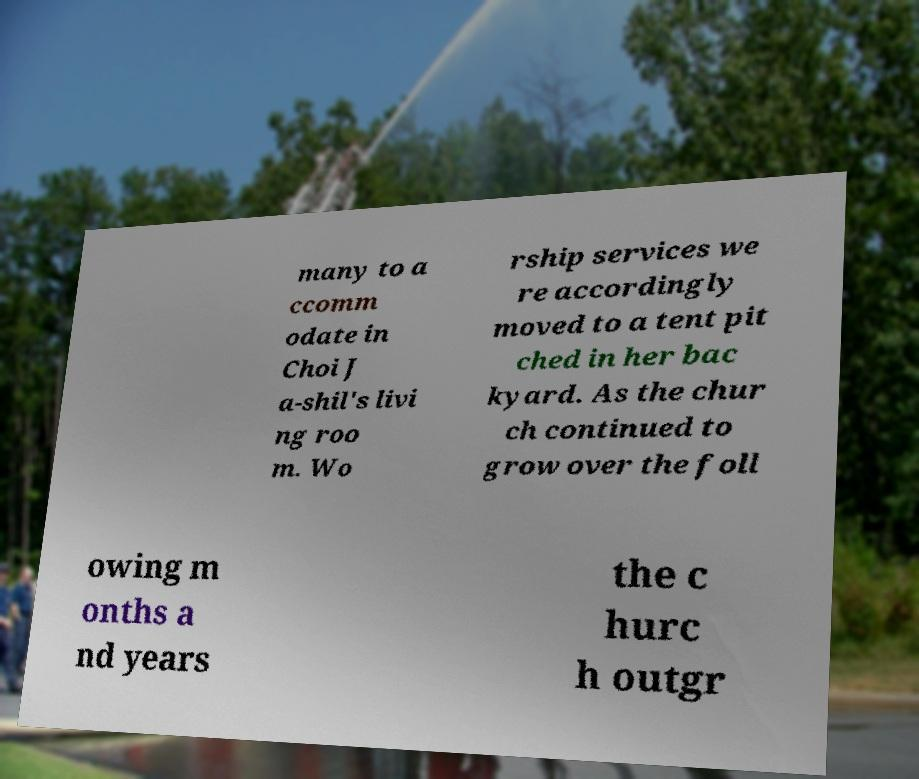Could you assist in decoding the text presented in this image and type it out clearly? many to a ccomm odate in Choi J a-shil's livi ng roo m. Wo rship services we re accordingly moved to a tent pit ched in her bac kyard. As the chur ch continued to grow over the foll owing m onths a nd years the c hurc h outgr 